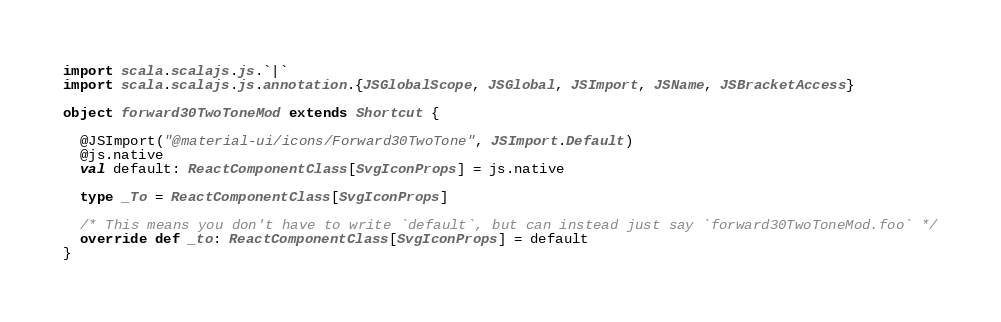<code> <loc_0><loc_0><loc_500><loc_500><_Scala_>import scala.scalajs.js.`|`
import scala.scalajs.js.annotation.{JSGlobalScope, JSGlobal, JSImport, JSName, JSBracketAccess}

object forward30TwoToneMod extends Shortcut {
  
  @JSImport("@material-ui/icons/Forward30TwoTone", JSImport.Default)
  @js.native
  val default: ReactComponentClass[SvgIconProps] = js.native
  
  type _To = ReactComponentClass[SvgIconProps]
  
  /* This means you don't have to write `default`, but can instead just say `forward30TwoToneMod.foo` */
  override def _to: ReactComponentClass[SvgIconProps] = default
}
</code> 